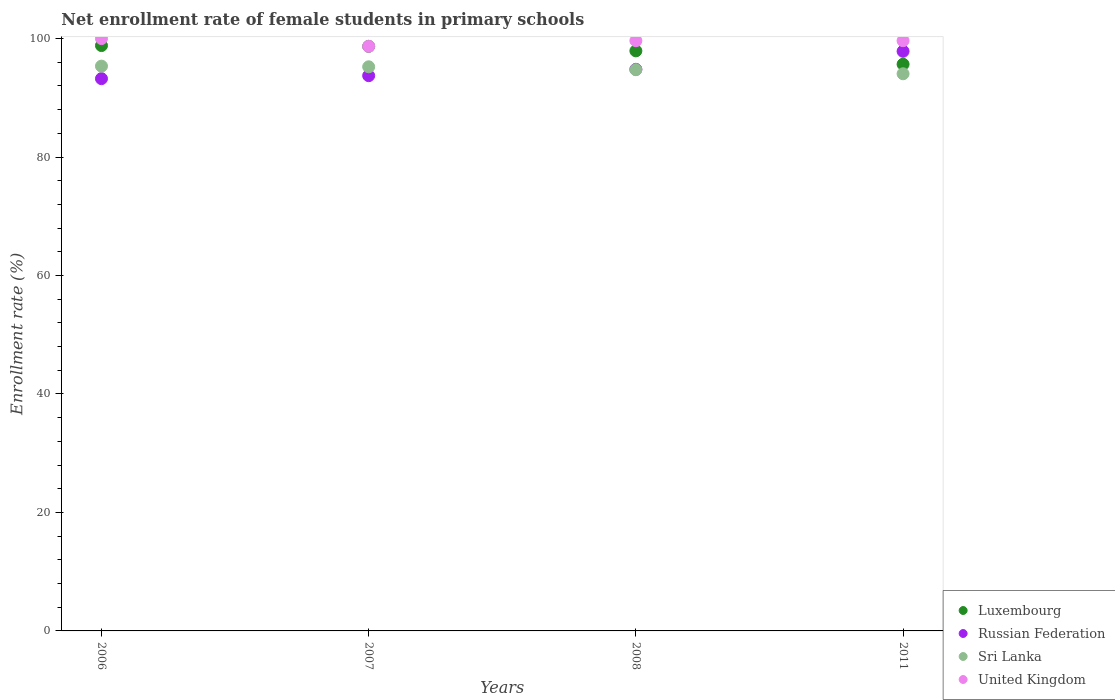How many different coloured dotlines are there?
Your response must be concise. 4. What is the net enrollment rate of female students in primary schools in Luxembourg in 2007?
Provide a succinct answer. 98.69. Across all years, what is the maximum net enrollment rate of female students in primary schools in United Kingdom?
Make the answer very short. 100. Across all years, what is the minimum net enrollment rate of female students in primary schools in United Kingdom?
Your response must be concise. 98.69. In which year was the net enrollment rate of female students in primary schools in United Kingdom minimum?
Offer a very short reply. 2007. What is the total net enrollment rate of female students in primary schools in Russian Federation in the graph?
Provide a succinct answer. 379.63. What is the difference between the net enrollment rate of female students in primary schools in Luxembourg in 2006 and that in 2011?
Offer a very short reply. 3.15. What is the difference between the net enrollment rate of female students in primary schools in Luxembourg in 2008 and the net enrollment rate of female students in primary schools in United Kingdom in 2007?
Offer a very short reply. -0.77. What is the average net enrollment rate of female students in primary schools in Sri Lanka per year?
Your answer should be compact. 94.85. In the year 2006, what is the difference between the net enrollment rate of female students in primary schools in Russian Federation and net enrollment rate of female students in primary schools in Luxembourg?
Your answer should be compact. -5.59. What is the ratio of the net enrollment rate of female students in primary schools in Sri Lanka in 2006 to that in 2008?
Provide a succinct answer. 1.01. What is the difference between the highest and the second highest net enrollment rate of female students in primary schools in Russian Federation?
Provide a succinct answer. 3.04. What is the difference between the highest and the lowest net enrollment rate of female students in primary schools in Russian Federation?
Provide a succinct answer. 4.62. In how many years, is the net enrollment rate of female students in primary schools in Russian Federation greater than the average net enrollment rate of female students in primary schools in Russian Federation taken over all years?
Give a very brief answer. 1. Is the sum of the net enrollment rate of female students in primary schools in United Kingdom in 2006 and 2008 greater than the maximum net enrollment rate of female students in primary schools in Russian Federation across all years?
Your answer should be compact. Yes. Does the net enrollment rate of female students in primary schools in United Kingdom monotonically increase over the years?
Offer a very short reply. No. Is the net enrollment rate of female students in primary schools in Luxembourg strictly greater than the net enrollment rate of female students in primary schools in Sri Lanka over the years?
Provide a short and direct response. Yes. How many years are there in the graph?
Ensure brevity in your answer.  4. Where does the legend appear in the graph?
Your answer should be compact. Bottom right. What is the title of the graph?
Offer a terse response. Net enrollment rate of female students in primary schools. What is the label or title of the X-axis?
Keep it short and to the point. Years. What is the label or title of the Y-axis?
Your answer should be compact. Enrollment rate (%). What is the Enrollment rate (%) in Luxembourg in 2006?
Offer a very short reply. 98.82. What is the Enrollment rate (%) of Russian Federation in 2006?
Provide a short and direct response. 93.23. What is the Enrollment rate (%) in Sri Lanka in 2006?
Provide a short and direct response. 95.35. What is the Enrollment rate (%) in United Kingdom in 2006?
Give a very brief answer. 100. What is the Enrollment rate (%) in Luxembourg in 2007?
Offer a terse response. 98.69. What is the Enrollment rate (%) in Russian Federation in 2007?
Provide a short and direct response. 93.73. What is the Enrollment rate (%) in Sri Lanka in 2007?
Give a very brief answer. 95.24. What is the Enrollment rate (%) in United Kingdom in 2007?
Offer a terse response. 98.69. What is the Enrollment rate (%) of Luxembourg in 2008?
Your answer should be very brief. 97.92. What is the Enrollment rate (%) in Russian Federation in 2008?
Your answer should be compact. 94.81. What is the Enrollment rate (%) in Sri Lanka in 2008?
Keep it short and to the point. 94.74. What is the Enrollment rate (%) of United Kingdom in 2008?
Your answer should be compact. 99.64. What is the Enrollment rate (%) of Luxembourg in 2011?
Provide a short and direct response. 95.67. What is the Enrollment rate (%) of Russian Federation in 2011?
Offer a terse response. 97.85. What is the Enrollment rate (%) in Sri Lanka in 2011?
Your answer should be compact. 94.06. What is the Enrollment rate (%) of United Kingdom in 2011?
Offer a very short reply. 99.64. Across all years, what is the maximum Enrollment rate (%) of Luxembourg?
Provide a succinct answer. 98.82. Across all years, what is the maximum Enrollment rate (%) of Russian Federation?
Offer a terse response. 97.85. Across all years, what is the maximum Enrollment rate (%) of Sri Lanka?
Provide a succinct answer. 95.35. Across all years, what is the maximum Enrollment rate (%) in United Kingdom?
Provide a succinct answer. 100. Across all years, what is the minimum Enrollment rate (%) of Luxembourg?
Provide a succinct answer. 95.67. Across all years, what is the minimum Enrollment rate (%) in Russian Federation?
Provide a short and direct response. 93.23. Across all years, what is the minimum Enrollment rate (%) in Sri Lanka?
Provide a short and direct response. 94.06. Across all years, what is the minimum Enrollment rate (%) in United Kingdom?
Provide a succinct answer. 98.69. What is the total Enrollment rate (%) of Luxembourg in the graph?
Offer a very short reply. 391.1. What is the total Enrollment rate (%) in Russian Federation in the graph?
Offer a very short reply. 379.63. What is the total Enrollment rate (%) in Sri Lanka in the graph?
Make the answer very short. 379.39. What is the total Enrollment rate (%) of United Kingdom in the graph?
Give a very brief answer. 397.97. What is the difference between the Enrollment rate (%) in Luxembourg in 2006 and that in 2007?
Your response must be concise. 0.13. What is the difference between the Enrollment rate (%) of Russian Federation in 2006 and that in 2007?
Provide a succinct answer. -0.5. What is the difference between the Enrollment rate (%) of Sri Lanka in 2006 and that in 2007?
Offer a very short reply. 0.11. What is the difference between the Enrollment rate (%) in United Kingdom in 2006 and that in 2007?
Keep it short and to the point. 1.31. What is the difference between the Enrollment rate (%) in Luxembourg in 2006 and that in 2008?
Offer a very short reply. 0.89. What is the difference between the Enrollment rate (%) in Russian Federation in 2006 and that in 2008?
Offer a terse response. -1.57. What is the difference between the Enrollment rate (%) in Sri Lanka in 2006 and that in 2008?
Offer a very short reply. 0.6. What is the difference between the Enrollment rate (%) of United Kingdom in 2006 and that in 2008?
Offer a very short reply. 0.36. What is the difference between the Enrollment rate (%) in Luxembourg in 2006 and that in 2011?
Your answer should be compact. 3.15. What is the difference between the Enrollment rate (%) in Russian Federation in 2006 and that in 2011?
Your response must be concise. -4.62. What is the difference between the Enrollment rate (%) of Sri Lanka in 2006 and that in 2011?
Your answer should be very brief. 1.29. What is the difference between the Enrollment rate (%) in United Kingdom in 2006 and that in 2011?
Your response must be concise. 0.36. What is the difference between the Enrollment rate (%) in Luxembourg in 2007 and that in 2008?
Your answer should be compact. 0.76. What is the difference between the Enrollment rate (%) in Russian Federation in 2007 and that in 2008?
Your answer should be compact. -1.07. What is the difference between the Enrollment rate (%) in Sri Lanka in 2007 and that in 2008?
Ensure brevity in your answer.  0.49. What is the difference between the Enrollment rate (%) of United Kingdom in 2007 and that in 2008?
Keep it short and to the point. -0.95. What is the difference between the Enrollment rate (%) of Luxembourg in 2007 and that in 2011?
Offer a very short reply. 3.02. What is the difference between the Enrollment rate (%) of Russian Federation in 2007 and that in 2011?
Make the answer very short. -4.12. What is the difference between the Enrollment rate (%) in Sri Lanka in 2007 and that in 2011?
Provide a short and direct response. 1.18. What is the difference between the Enrollment rate (%) in United Kingdom in 2007 and that in 2011?
Provide a short and direct response. -0.95. What is the difference between the Enrollment rate (%) of Luxembourg in 2008 and that in 2011?
Keep it short and to the point. 2.26. What is the difference between the Enrollment rate (%) of Russian Federation in 2008 and that in 2011?
Ensure brevity in your answer.  -3.04. What is the difference between the Enrollment rate (%) in Sri Lanka in 2008 and that in 2011?
Ensure brevity in your answer.  0.69. What is the difference between the Enrollment rate (%) of United Kingdom in 2008 and that in 2011?
Offer a very short reply. -0. What is the difference between the Enrollment rate (%) in Luxembourg in 2006 and the Enrollment rate (%) in Russian Federation in 2007?
Provide a short and direct response. 5.08. What is the difference between the Enrollment rate (%) in Luxembourg in 2006 and the Enrollment rate (%) in Sri Lanka in 2007?
Your response must be concise. 3.58. What is the difference between the Enrollment rate (%) in Luxembourg in 2006 and the Enrollment rate (%) in United Kingdom in 2007?
Give a very brief answer. 0.13. What is the difference between the Enrollment rate (%) of Russian Federation in 2006 and the Enrollment rate (%) of Sri Lanka in 2007?
Provide a short and direct response. -2. What is the difference between the Enrollment rate (%) in Russian Federation in 2006 and the Enrollment rate (%) in United Kingdom in 2007?
Your response must be concise. -5.46. What is the difference between the Enrollment rate (%) of Sri Lanka in 2006 and the Enrollment rate (%) of United Kingdom in 2007?
Provide a succinct answer. -3.35. What is the difference between the Enrollment rate (%) in Luxembourg in 2006 and the Enrollment rate (%) in Russian Federation in 2008?
Keep it short and to the point. 4.01. What is the difference between the Enrollment rate (%) of Luxembourg in 2006 and the Enrollment rate (%) of Sri Lanka in 2008?
Keep it short and to the point. 4.07. What is the difference between the Enrollment rate (%) of Luxembourg in 2006 and the Enrollment rate (%) of United Kingdom in 2008?
Offer a terse response. -0.82. What is the difference between the Enrollment rate (%) in Russian Federation in 2006 and the Enrollment rate (%) in Sri Lanka in 2008?
Provide a short and direct response. -1.51. What is the difference between the Enrollment rate (%) in Russian Federation in 2006 and the Enrollment rate (%) in United Kingdom in 2008?
Provide a succinct answer. -6.41. What is the difference between the Enrollment rate (%) of Sri Lanka in 2006 and the Enrollment rate (%) of United Kingdom in 2008?
Offer a very short reply. -4.29. What is the difference between the Enrollment rate (%) in Luxembourg in 2006 and the Enrollment rate (%) in Russian Federation in 2011?
Provide a short and direct response. 0.97. What is the difference between the Enrollment rate (%) of Luxembourg in 2006 and the Enrollment rate (%) of Sri Lanka in 2011?
Make the answer very short. 4.76. What is the difference between the Enrollment rate (%) of Luxembourg in 2006 and the Enrollment rate (%) of United Kingdom in 2011?
Offer a terse response. -0.82. What is the difference between the Enrollment rate (%) in Russian Federation in 2006 and the Enrollment rate (%) in Sri Lanka in 2011?
Provide a succinct answer. -0.83. What is the difference between the Enrollment rate (%) in Russian Federation in 2006 and the Enrollment rate (%) in United Kingdom in 2011?
Your response must be concise. -6.41. What is the difference between the Enrollment rate (%) of Sri Lanka in 2006 and the Enrollment rate (%) of United Kingdom in 2011?
Offer a terse response. -4.29. What is the difference between the Enrollment rate (%) in Luxembourg in 2007 and the Enrollment rate (%) in Russian Federation in 2008?
Provide a short and direct response. 3.88. What is the difference between the Enrollment rate (%) in Luxembourg in 2007 and the Enrollment rate (%) in Sri Lanka in 2008?
Make the answer very short. 3.94. What is the difference between the Enrollment rate (%) in Luxembourg in 2007 and the Enrollment rate (%) in United Kingdom in 2008?
Your response must be concise. -0.95. What is the difference between the Enrollment rate (%) of Russian Federation in 2007 and the Enrollment rate (%) of Sri Lanka in 2008?
Offer a very short reply. -1.01. What is the difference between the Enrollment rate (%) in Russian Federation in 2007 and the Enrollment rate (%) in United Kingdom in 2008?
Provide a succinct answer. -5.91. What is the difference between the Enrollment rate (%) of Sri Lanka in 2007 and the Enrollment rate (%) of United Kingdom in 2008?
Provide a short and direct response. -4.41. What is the difference between the Enrollment rate (%) in Luxembourg in 2007 and the Enrollment rate (%) in Russian Federation in 2011?
Give a very brief answer. 0.84. What is the difference between the Enrollment rate (%) of Luxembourg in 2007 and the Enrollment rate (%) of Sri Lanka in 2011?
Your response must be concise. 4.63. What is the difference between the Enrollment rate (%) in Luxembourg in 2007 and the Enrollment rate (%) in United Kingdom in 2011?
Ensure brevity in your answer.  -0.95. What is the difference between the Enrollment rate (%) in Russian Federation in 2007 and the Enrollment rate (%) in Sri Lanka in 2011?
Make the answer very short. -0.32. What is the difference between the Enrollment rate (%) of Russian Federation in 2007 and the Enrollment rate (%) of United Kingdom in 2011?
Provide a succinct answer. -5.91. What is the difference between the Enrollment rate (%) of Sri Lanka in 2007 and the Enrollment rate (%) of United Kingdom in 2011?
Provide a short and direct response. -4.41. What is the difference between the Enrollment rate (%) of Luxembourg in 2008 and the Enrollment rate (%) of Russian Federation in 2011?
Give a very brief answer. 0.07. What is the difference between the Enrollment rate (%) of Luxembourg in 2008 and the Enrollment rate (%) of Sri Lanka in 2011?
Provide a succinct answer. 3.87. What is the difference between the Enrollment rate (%) in Luxembourg in 2008 and the Enrollment rate (%) in United Kingdom in 2011?
Your answer should be compact. -1.72. What is the difference between the Enrollment rate (%) in Russian Federation in 2008 and the Enrollment rate (%) in Sri Lanka in 2011?
Make the answer very short. 0.75. What is the difference between the Enrollment rate (%) in Russian Federation in 2008 and the Enrollment rate (%) in United Kingdom in 2011?
Ensure brevity in your answer.  -4.83. What is the difference between the Enrollment rate (%) in Sri Lanka in 2008 and the Enrollment rate (%) in United Kingdom in 2011?
Your answer should be very brief. -4.9. What is the average Enrollment rate (%) of Luxembourg per year?
Provide a short and direct response. 97.77. What is the average Enrollment rate (%) in Russian Federation per year?
Provide a short and direct response. 94.91. What is the average Enrollment rate (%) in Sri Lanka per year?
Your answer should be very brief. 94.85. What is the average Enrollment rate (%) of United Kingdom per year?
Make the answer very short. 99.49. In the year 2006, what is the difference between the Enrollment rate (%) in Luxembourg and Enrollment rate (%) in Russian Federation?
Make the answer very short. 5.59. In the year 2006, what is the difference between the Enrollment rate (%) of Luxembourg and Enrollment rate (%) of Sri Lanka?
Ensure brevity in your answer.  3.47. In the year 2006, what is the difference between the Enrollment rate (%) in Luxembourg and Enrollment rate (%) in United Kingdom?
Your answer should be very brief. -1.18. In the year 2006, what is the difference between the Enrollment rate (%) of Russian Federation and Enrollment rate (%) of Sri Lanka?
Your answer should be very brief. -2.11. In the year 2006, what is the difference between the Enrollment rate (%) of Russian Federation and Enrollment rate (%) of United Kingdom?
Ensure brevity in your answer.  -6.77. In the year 2006, what is the difference between the Enrollment rate (%) of Sri Lanka and Enrollment rate (%) of United Kingdom?
Ensure brevity in your answer.  -4.65. In the year 2007, what is the difference between the Enrollment rate (%) in Luxembourg and Enrollment rate (%) in Russian Federation?
Provide a succinct answer. 4.95. In the year 2007, what is the difference between the Enrollment rate (%) in Luxembourg and Enrollment rate (%) in Sri Lanka?
Provide a succinct answer. 3.45. In the year 2007, what is the difference between the Enrollment rate (%) in Luxembourg and Enrollment rate (%) in United Kingdom?
Provide a succinct answer. -0.01. In the year 2007, what is the difference between the Enrollment rate (%) in Russian Federation and Enrollment rate (%) in Sri Lanka?
Keep it short and to the point. -1.5. In the year 2007, what is the difference between the Enrollment rate (%) in Russian Federation and Enrollment rate (%) in United Kingdom?
Ensure brevity in your answer.  -4.96. In the year 2007, what is the difference between the Enrollment rate (%) in Sri Lanka and Enrollment rate (%) in United Kingdom?
Your answer should be very brief. -3.46. In the year 2008, what is the difference between the Enrollment rate (%) of Luxembourg and Enrollment rate (%) of Russian Federation?
Provide a succinct answer. 3.12. In the year 2008, what is the difference between the Enrollment rate (%) of Luxembourg and Enrollment rate (%) of Sri Lanka?
Ensure brevity in your answer.  3.18. In the year 2008, what is the difference between the Enrollment rate (%) in Luxembourg and Enrollment rate (%) in United Kingdom?
Offer a terse response. -1.72. In the year 2008, what is the difference between the Enrollment rate (%) in Russian Federation and Enrollment rate (%) in Sri Lanka?
Provide a short and direct response. 0.06. In the year 2008, what is the difference between the Enrollment rate (%) of Russian Federation and Enrollment rate (%) of United Kingdom?
Make the answer very short. -4.83. In the year 2008, what is the difference between the Enrollment rate (%) of Sri Lanka and Enrollment rate (%) of United Kingdom?
Your answer should be compact. -4.9. In the year 2011, what is the difference between the Enrollment rate (%) in Luxembourg and Enrollment rate (%) in Russian Federation?
Offer a terse response. -2.19. In the year 2011, what is the difference between the Enrollment rate (%) of Luxembourg and Enrollment rate (%) of Sri Lanka?
Give a very brief answer. 1.61. In the year 2011, what is the difference between the Enrollment rate (%) in Luxembourg and Enrollment rate (%) in United Kingdom?
Offer a very short reply. -3.97. In the year 2011, what is the difference between the Enrollment rate (%) in Russian Federation and Enrollment rate (%) in Sri Lanka?
Offer a very short reply. 3.79. In the year 2011, what is the difference between the Enrollment rate (%) in Russian Federation and Enrollment rate (%) in United Kingdom?
Provide a succinct answer. -1.79. In the year 2011, what is the difference between the Enrollment rate (%) of Sri Lanka and Enrollment rate (%) of United Kingdom?
Your answer should be compact. -5.58. What is the ratio of the Enrollment rate (%) of United Kingdom in 2006 to that in 2007?
Give a very brief answer. 1.01. What is the ratio of the Enrollment rate (%) of Luxembourg in 2006 to that in 2008?
Give a very brief answer. 1.01. What is the ratio of the Enrollment rate (%) in Russian Federation in 2006 to that in 2008?
Offer a terse response. 0.98. What is the ratio of the Enrollment rate (%) of Sri Lanka in 2006 to that in 2008?
Give a very brief answer. 1.01. What is the ratio of the Enrollment rate (%) in Luxembourg in 2006 to that in 2011?
Give a very brief answer. 1.03. What is the ratio of the Enrollment rate (%) of Russian Federation in 2006 to that in 2011?
Give a very brief answer. 0.95. What is the ratio of the Enrollment rate (%) of Sri Lanka in 2006 to that in 2011?
Your answer should be compact. 1.01. What is the ratio of the Enrollment rate (%) of United Kingdom in 2006 to that in 2011?
Your answer should be compact. 1. What is the ratio of the Enrollment rate (%) of Luxembourg in 2007 to that in 2008?
Your answer should be very brief. 1.01. What is the ratio of the Enrollment rate (%) in Russian Federation in 2007 to that in 2008?
Provide a short and direct response. 0.99. What is the ratio of the Enrollment rate (%) in Sri Lanka in 2007 to that in 2008?
Ensure brevity in your answer.  1.01. What is the ratio of the Enrollment rate (%) in United Kingdom in 2007 to that in 2008?
Offer a very short reply. 0.99. What is the ratio of the Enrollment rate (%) in Luxembourg in 2007 to that in 2011?
Make the answer very short. 1.03. What is the ratio of the Enrollment rate (%) in Russian Federation in 2007 to that in 2011?
Provide a succinct answer. 0.96. What is the ratio of the Enrollment rate (%) of Sri Lanka in 2007 to that in 2011?
Provide a short and direct response. 1.01. What is the ratio of the Enrollment rate (%) in Luxembourg in 2008 to that in 2011?
Your answer should be compact. 1.02. What is the ratio of the Enrollment rate (%) of Russian Federation in 2008 to that in 2011?
Your answer should be compact. 0.97. What is the ratio of the Enrollment rate (%) of Sri Lanka in 2008 to that in 2011?
Your answer should be very brief. 1.01. What is the difference between the highest and the second highest Enrollment rate (%) in Luxembourg?
Your answer should be very brief. 0.13. What is the difference between the highest and the second highest Enrollment rate (%) in Russian Federation?
Provide a short and direct response. 3.04. What is the difference between the highest and the second highest Enrollment rate (%) of Sri Lanka?
Your response must be concise. 0.11. What is the difference between the highest and the second highest Enrollment rate (%) in United Kingdom?
Offer a terse response. 0.36. What is the difference between the highest and the lowest Enrollment rate (%) of Luxembourg?
Provide a succinct answer. 3.15. What is the difference between the highest and the lowest Enrollment rate (%) of Russian Federation?
Keep it short and to the point. 4.62. What is the difference between the highest and the lowest Enrollment rate (%) of Sri Lanka?
Keep it short and to the point. 1.29. What is the difference between the highest and the lowest Enrollment rate (%) of United Kingdom?
Your answer should be compact. 1.31. 